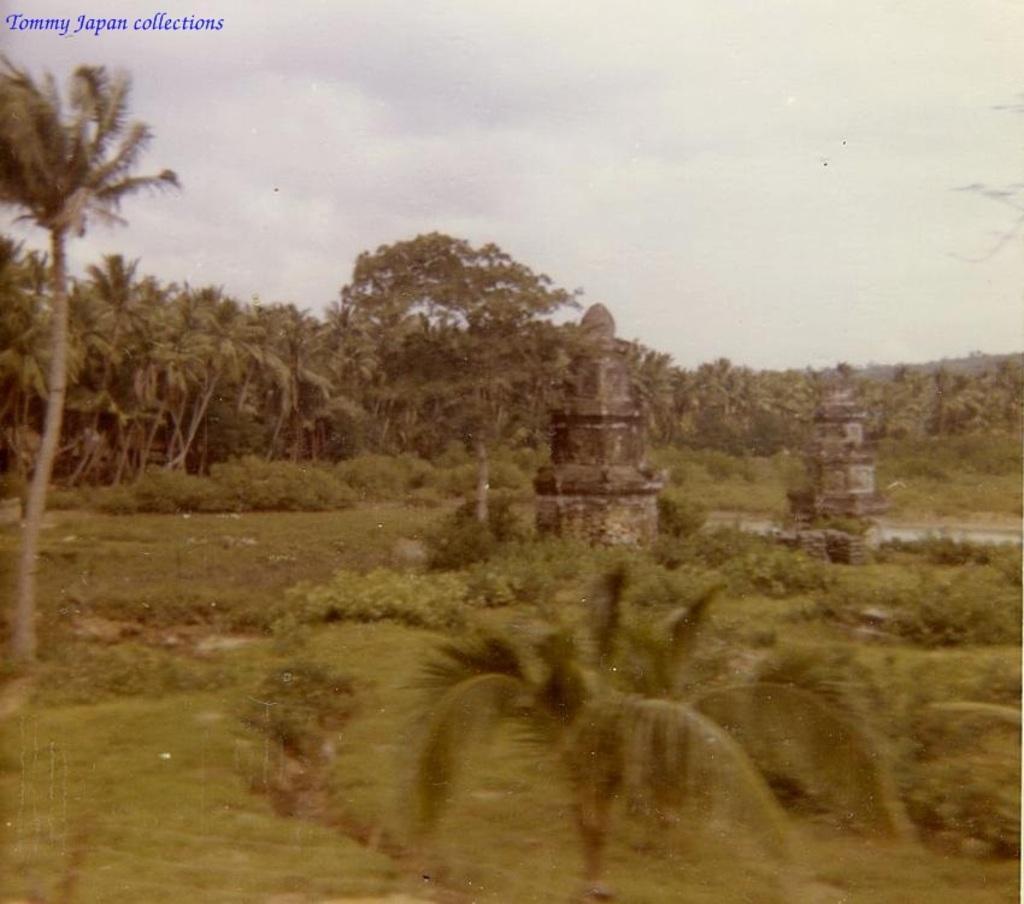Could you give a brief overview of what you see in this image? In this image we can see some trees and plants. We can also see two pillars on the surface and the sky. 